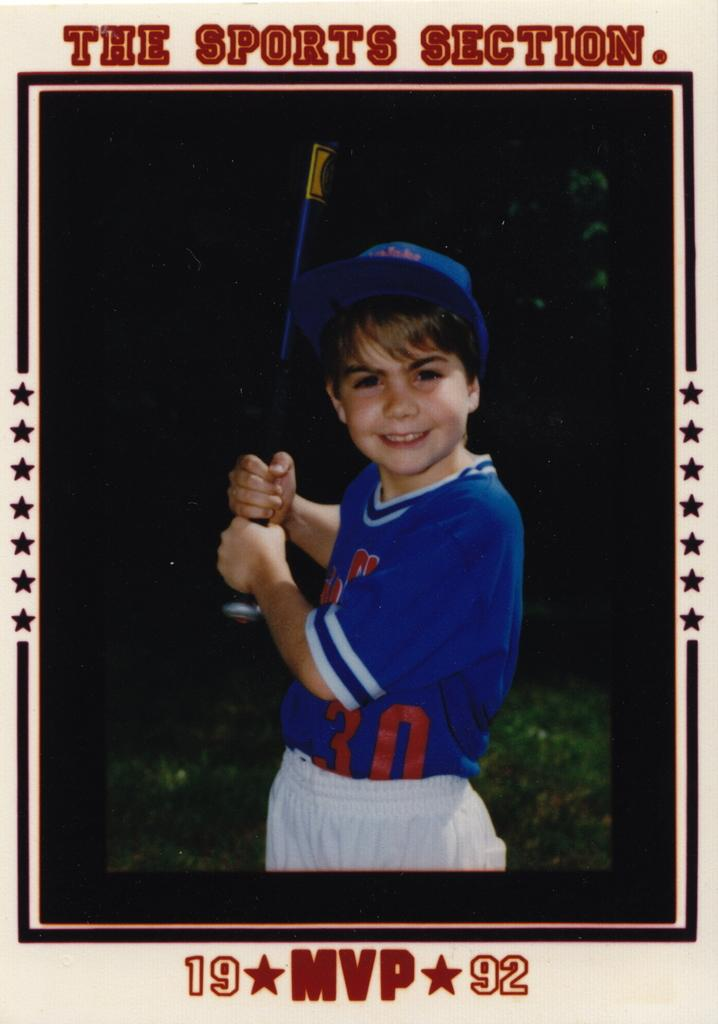<image>
Create a compact narrative representing the image presented. A young boy in a photo is labeled a 1992 MVP. 